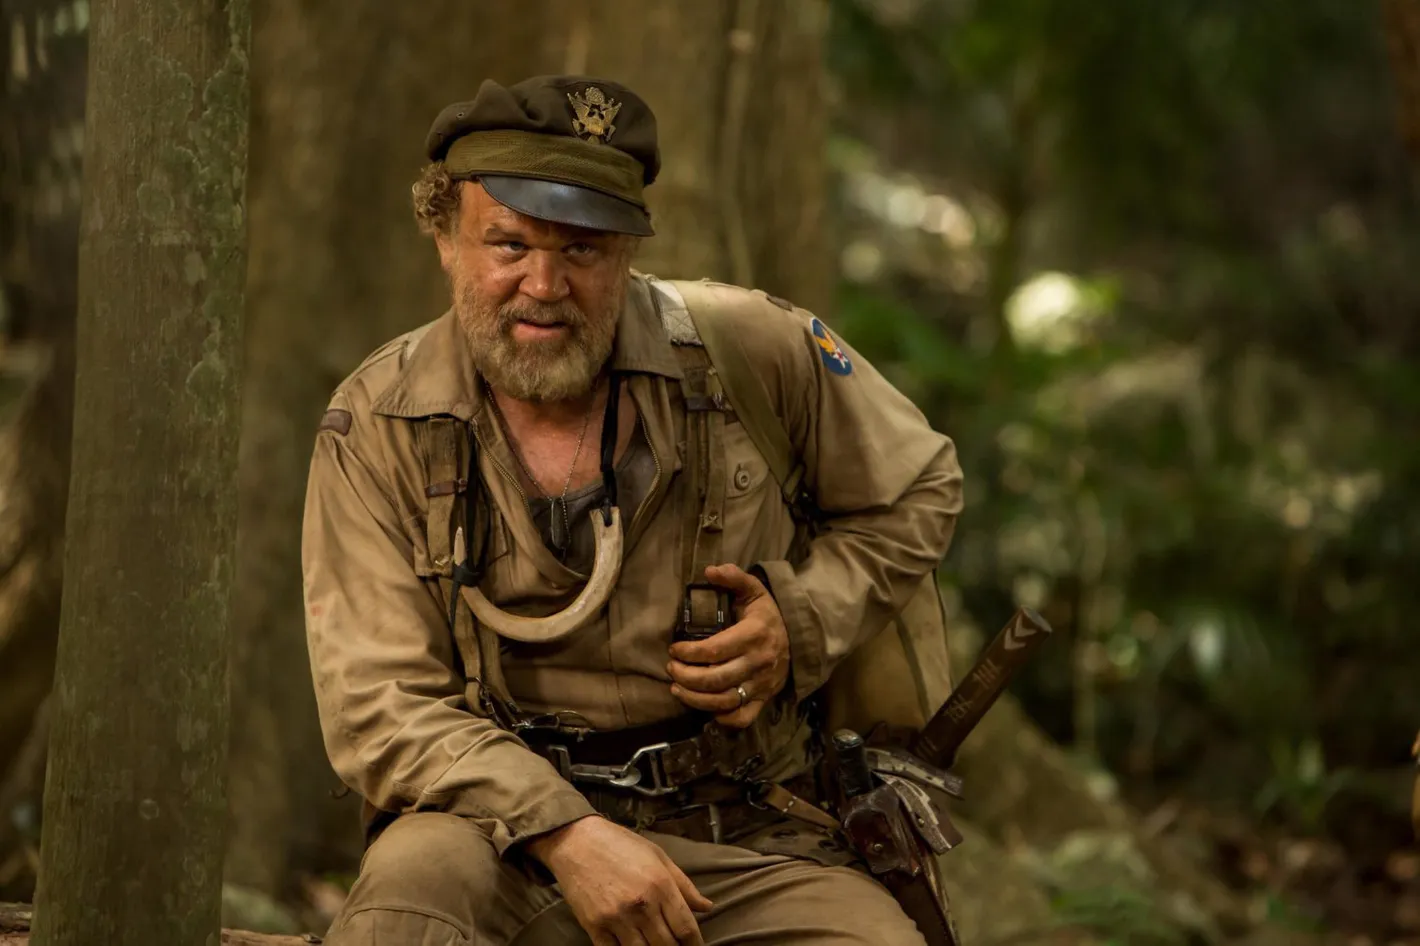You mentioned he is in deep contemplation. What might be going through his mind in this moment? In this moment of deep contemplation, the character might be reflecting on his long and arduous journey. He could be reminiscing about his past life, before he found himself in this remote jungle, recalling moments of camaraderie with his fellow soldiers, the battles he fought, and the personal losses he suffered. The solitude and silence of the jungle might bring forth thoughts about the choices he made and their consequences, the loved ones he left behind, and the haunting memories of war. He could also be strategizing his next steps, assessing potential threats, and planning how to navigate the treacherous terrain. This moment of introspection might also be a time for him to seek inner peace, trying to reconcile with his past and find a sense of purpose in what lies ahead in the untamed wilderness. What if he is contemplating a decision that could change his fate? If he is contemplating a decision that could change his fate, his mind is likely a battlefield of conflicting thoughts and emotions. He might be weighing the risks and benefits of a pivotal choice – perhaps deciding whether to leave the safety of his current position to embark on a perilous journey in search of a rumored safe haven or a person of interest. He could be considering reaching out to a potential ally, risking betrayal but also the possibility of gaining invaluable support. Alternatively, he might be contemplating a final stand, choosing to confront a looming threat face-to-face, despite the odds. The gravity of this decision would bring a sense of urgency and tension to his contemplation, as he understands that whichever path he chooses, it will irrevocably alter the course of his life. The surrounding jungle, with its silence and natural presence, offers a poignant and almost spiritual backdrop for this critical moment of decision-making. 